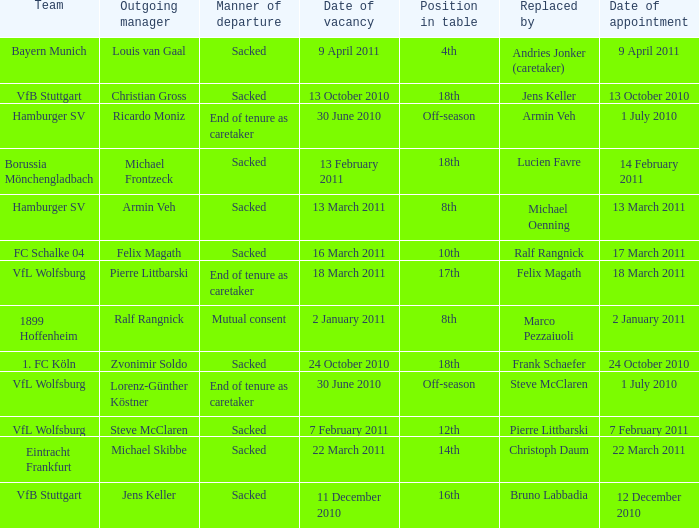When steve mcclaren is the replacer what is the manner of departure? End of tenure as caretaker. 